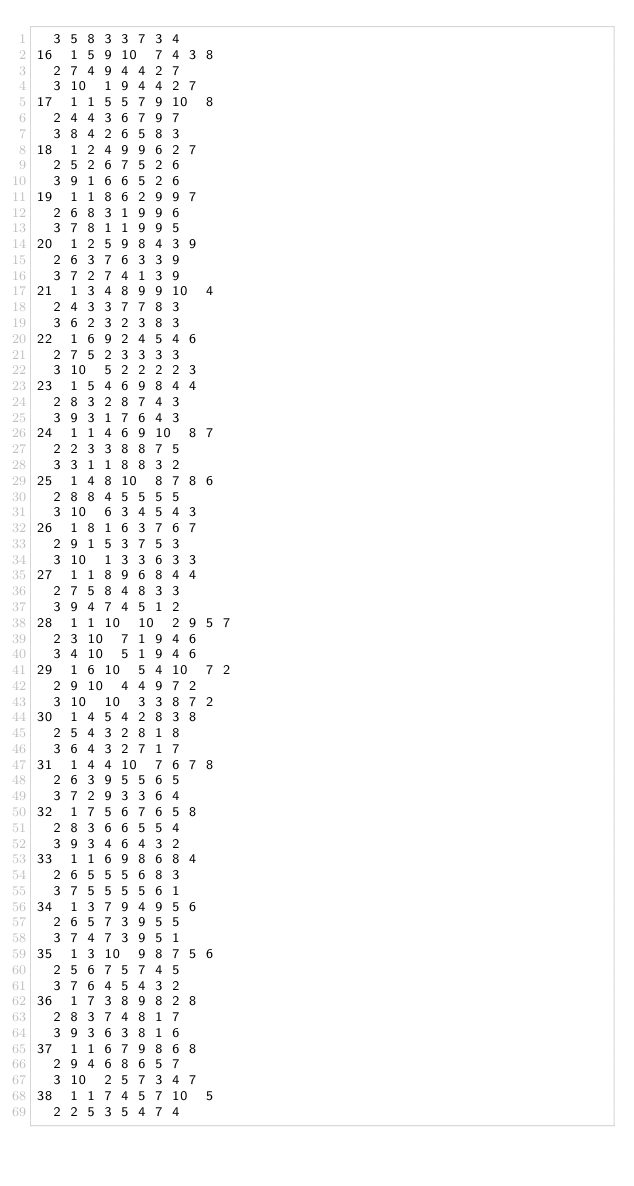Convert code to text. <code><loc_0><loc_0><loc_500><loc_500><_ObjectiveC_>	3	5	8	3	3	7	3	4	
16	1	5	9	10	7	4	3	8	
	2	7	4	9	4	4	2	7	
	3	10	1	9	4	4	2	7	
17	1	1	5	5	7	9	10	8	
	2	4	4	3	6	7	9	7	
	3	8	4	2	6	5	8	3	
18	1	2	4	9	9	6	2	7	
	2	5	2	6	7	5	2	6	
	3	9	1	6	6	5	2	6	
19	1	1	8	6	2	9	9	7	
	2	6	8	3	1	9	9	6	
	3	7	8	1	1	9	9	5	
20	1	2	5	9	8	4	3	9	
	2	6	3	7	6	3	3	9	
	3	7	2	7	4	1	3	9	
21	1	3	4	8	9	9	10	4	
	2	4	3	3	7	7	8	3	
	3	6	2	3	2	3	8	3	
22	1	6	9	2	4	5	4	6	
	2	7	5	2	3	3	3	3	
	3	10	5	2	2	2	2	3	
23	1	5	4	6	9	8	4	4	
	2	8	3	2	8	7	4	3	
	3	9	3	1	7	6	4	3	
24	1	1	4	6	9	10	8	7	
	2	2	3	3	8	8	7	5	
	3	3	1	1	8	8	3	2	
25	1	4	8	10	8	7	8	6	
	2	8	8	4	5	5	5	5	
	3	10	6	3	4	5	4	3	
26	1	8	1	6	3	7	6	7	
	2	9	1	5	3	7	5	3	
	3	10	1	3	3	6	3	3	
27	1	1	8	9	6	8	4	4	
	2	7	5	8	4	8	3	3	
	3	9	4	7	4	5	1	2	
28	1	1	10	10	2	9	5	7	
	2	3	10	7	1	9	4	6	
	3	4	10	5	1	9	4	6	
29	1	6	10	5	4	10	7	2	
	2	9	10	4	4	9	7	2	
	3	10	10	3	3	8	7	2	
30	1	4	5	4	2	8	3	8	
	2	5	4	3	2	8	1	8	
	3	6	4	3	2	7	1	7	
31	1	4	4	10	7	6	7	8	
	2	6	3	9	5	5	6	5	
	3	7	2	9	3	3	6	4	
32	1	7	5	6	7	6	5	8	
	2	8	3	6	6	5	5	4	
	3	9	3	4	6	4	3	2	
33	1	1	6	9	8	6	8	4	
	2	6	5	5	5	6	8	3	
	3	7	5	5	5	5	6	1	
34	1	3	7	9	4	9	5	6	
	2	6	5	7	3	9	5	5	
	3	7	4	7	3	9	5	1	
35	1	3	10	9	8	7	5	6	
	2	5	6	7	5	7	4	5	
	3	7	6	4	5	4	3	2	
36	1	7	3	8	9	8	2	8	
	2	8	3	7	4	8	1	7	
	3	9	3	6	3	8	1	6	
37	1	1	6	7	9	8	6	8	
	2	9	4	6	8	6	5	7	
	3	10	2	5	7	3	4	7	
38	1	1	7	4	5	7	10	5	
	2	2	5	3	5	4	7	4	</code> 